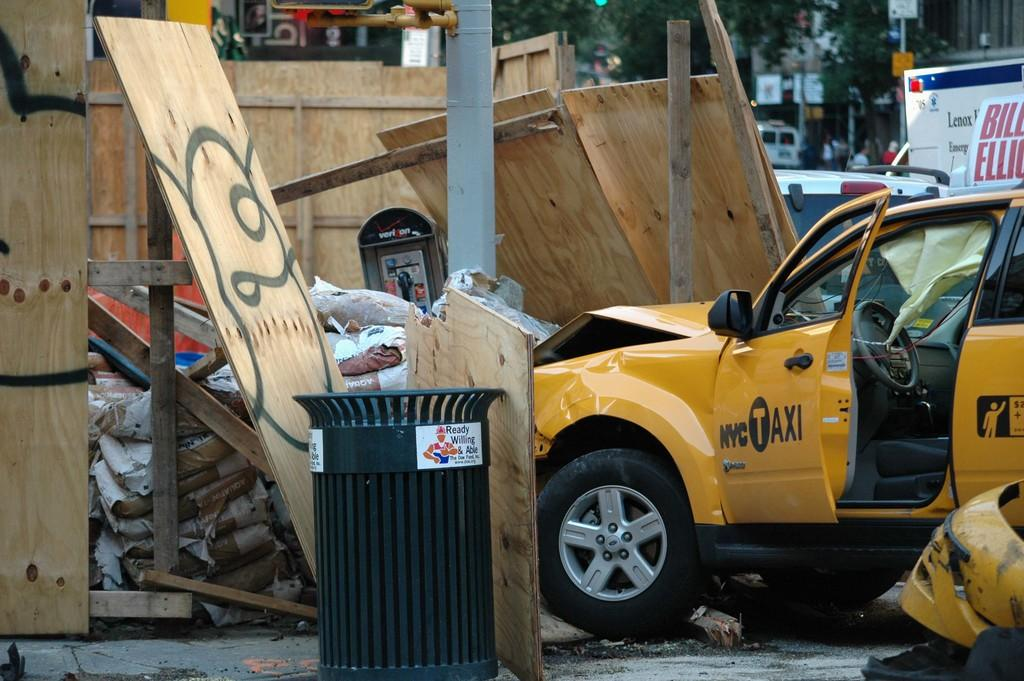<image>
Offer a succinct explanation of the picture presented. A yellow car with its door open; the door reads NYC Taxi. 